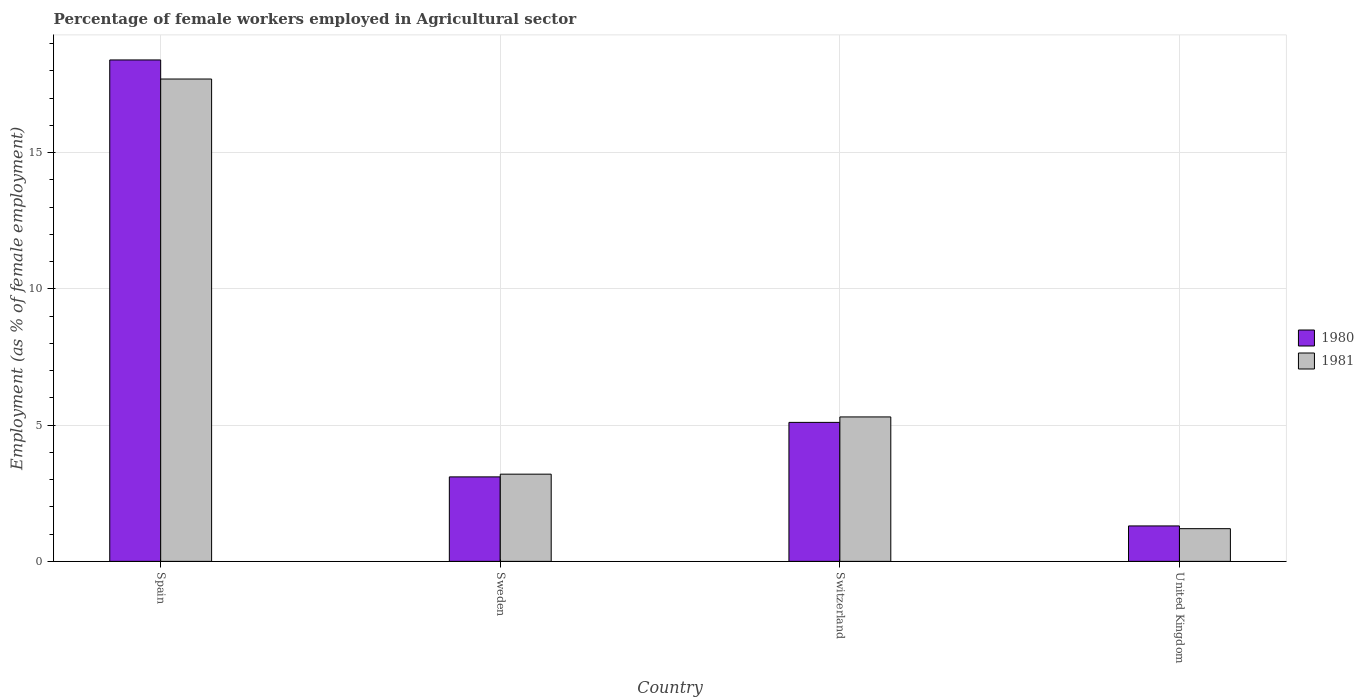How many groups of bars are there?
Offer a terse response. 4. Are the number of bars per tick equal to the number of legend labels?
Provide a succinct answer. Yes. Are the number of bars on each tick of the X-axis equal?
Ensure brevity in your answer.  Yes. What is the label of the 4th group of bars from the left?
Your answer should be very brief. United Kingdom. What is the percentage of females employed in Agricultural sector in 1980 in Spain?
Ensure brevity in your answer.  18.4. Across all countries, what is the maximum percentage of females employed in Agricultural sector in 1980?
Your answer should be very brief. 18.4. Across all countries, what is the minimum percentage of females employed in Agricultural sector in 1981?
Your answer should be compact. 1.2. What is the total percentage of females employed in Agricultural sector in 1980 in the graph?
Offer a very short reply. 27.9. What is the difference between the percentage of females employed in Agricultural sector in 1981 in Spain and that in United Kingdom?
Provide a short and direct response. 16.5. What is the difference between the percentage of females employed in Agricultural sector in 1981 in United Kingdom and the percentage of females employed in Agricultural sector in 1980 in Spain?
Your response must be concise. -17.2. What is the average percentage of females employed in Agricultural sector in 1980 per country?
Your response must be concise. 6.97. What is the difference between the percentage of females employed in Agricultural sector of/in 1981 and percentage of females employed in Agricultural sector of/in 1980 in United Kingdom?
Offer a very short reply. -0.1. What is the ratio of the percentage of females employed in Agricultural sector in 1981 in Switzerland to that in United Kingdom?
Offer a terse response. 4.42. What is the difference between the highest and the second highest percentage of females employed in Agricultural sector in 1980?
Your answer should be compact. 15.3. What is the difference between the highest and the lowest percentage of females employed in Agricultural sector in 1981?
Your answer should be very brief. 16.5. Is the sum of the percentage of females employed in Agricultural sector in 1981 in Spain and Sweden greater than the maximum percentage of females employed in Agricultural sector in 1980 across all countries?
Provide a succinct answer. Yes. What does the 1st bar from the left in Spain represents?
Your response must be concise. 1980. What does the 2nd bar from the right in United Kingdom represents?
Offer a very short reply. 1980. What is the difference between two consecutive major ticks on the Y-axis?
Your response must be concise. 5. Does the graph contain grids?
Provide a short and direct response. Yes. Where does the legend appear in the graph?
Provide a short and direct response. Center right. How many legend labels are there?
Your response must be concise. 2. How are the legend labels stacked?
Your response must be concise. Vertical. What is the title of the graph?
Your response must be concise. Percentage of female workers employed in Agricultural sector. Does "1998" appear as one of the legend labels in the graph?
Offer a terse response. No. What is the label or title of the Y-axis?
Keep it short and to the point. Employment (as % of female employment). What is the Employment (as % of female employment) of 1980 in Spain?
Make the answer very short. 18.4. What is the Employment (as % of female employment) of 1981 in Spain?
Provide a succinct answer. 17.7. What is the Employment (as % of female employment) of 1980 in Sweden?
Your answer should be compact. 3.1. What is the Employment (as % of female employment) of 1981 in Sweden?
Ensure brevity in your answer.  3.2. What is the Employment (as % of female employment) in 1980 in Switzerland?
Provide a succinct answer. 5.1. What is the Employment (as % of female employment) in 1981 in Switzerland?
Ensure brevity in your answer.  5.3. What is the Employment (as % of female employment) in 1980 in United Kingdom?
Provide a succinct answer. 1.3. What is the Employment (as % of female employment) of 1981 in United Kingdom?
Make the answer very short. 1.2. Across all countries, what is the maximum Employment (as % of female employment) of 1980?
Your answer should be compact. 18.4. Across all countries, what is the maximum Employment (as % of female employment) in 1981?
Your response must be concise. 17.7. Across all countries, what is the minimum Employment (as % of female employment) in 1980?
Keep it short and to the point. 1.3. Across all countries, what is the minimum Employment (as % of female employment) in 1981?
Your response must be concise. 1.2. What is the total Employment (as % of female employment) in 1980 in the graph?
Your response must be concise. 27.9. What is the total Employment (as % of female employment) in 1981 in the graph?
Your response must be concise. 27.4. What is the difference between the Employment (as % of female employment) of 1980 in Spain and that in Sweden?
Offer a very short reply. 15.3. What is the difference between the Employment (as % of female employment) in 1981 in Spain and that in Sweden?
Provide a succinct answer. 14.5. What is the difference between the Employment (as % of female employment) of 1981 in Spain and that in United Kingdom?
Keep it short and to the point. 16.5. What is the difference between the Employment (as % of female employment) of 1980 in Sweden and that in Switzerland?
Give a very brief answer. -2. What is the difference between the Employment (as % of female employment) of 1981 in Sweden and that in Switzerland?
Your response must be concise. -2.1. What is the difference between the Employment (as % of female employment) in 1981 in Switzerland and that in United Kingdom?
Offer a very short reply. 4.1. What is the difference between the Employment (as % of female employment) of 1980 in Spain and the Employment (as % of female employment) of 1981 in United Kingdom?
Make the answer very short. 17.2. What is the difference between the Employment (as % of female employment) of 1980 in Sweden and the Employment (as % of female employment) of 1981 in United Kingdom?
Give a very brief answer. 1.9. What is the average Employment (as % of female employment) in 1980 per country?
Make the answer very short. 6.97. What is the average Employment (as % of female employment) in 1981 per country?
Offer a very short reply. 6.85. What is the difference between the Employment (as % of female employment) in 1980 and Employment (as % of female employment) in 1981 in Sweden?
Make the answer very short. -0.1. What is the difference between the Employment (as % of female employment) in 1980 and Employment (as % of female employment) in 1981 in Switzerland?
Make the answer very short. -0.2. What is the ratio of the Employment (as % of female employment) in 1980 in Spain to that in Sweden?
Your answer should be very brief. 5.94. What is the ratio of the Employment (as % of female employment) in 1981 in Spain to that in Sweden?
Give a very brief answer. 5.53. What is the ratio of the Employment (as % of female employment) of 1980 in Spain to that in Switzerland?
Offer a terse response. 3.61. What is the ratio of the Employment (as % of female employment) in 1981 in Spain to that in Switzerland?
Offer a terse response. 3.34. What is the ratio of the Employment (as % of female employment) of 1980 in Spain to that in United Kingdom?
Your answer should be compact. 14.15. What is the ratio of the Employment (as % of female employment) of 1981 in Spain to that in United Kingdom?
Keep it short and to the point. 14.75. What is the ratio of the Employment (as % of female employment) of 1980 in Sweden to that in Switzerland?
Provide a succinct answer. 0.61. What is the ratio of the Employment (as % of female employment) in 1981 in Sweden to that in Switzerland?
Provide a succinct answer. 0.6. What is the ratio of the Employment (as % of female employment) in 1980 in Sweden to that in United Kingdom?
Give a very brief answer. 2.38. What is the ratio of the Employment (as % of female employment) of 1981 in Sweden to that in United Kingdom?
Your response must be concise. 2.67. What is the ratio of the Employment (as % of female employment) in 1980 in Switzerland to that in United Kingdom?
Your response must be concise. 3.92. What is the ratio of the Employment (as % of female employment) in 1981 in Switzerland to that in United Kingdom?
Give a very brief answer. 4.42. What is the difference between the highest and the second highest Employment (as % of female employment) of 1981?
Provide a succinct answer. 12.4. What is the difference between the highest and the lowest Employment (as % of female employment) of 1981?
Offer a terse response. 16.5. 